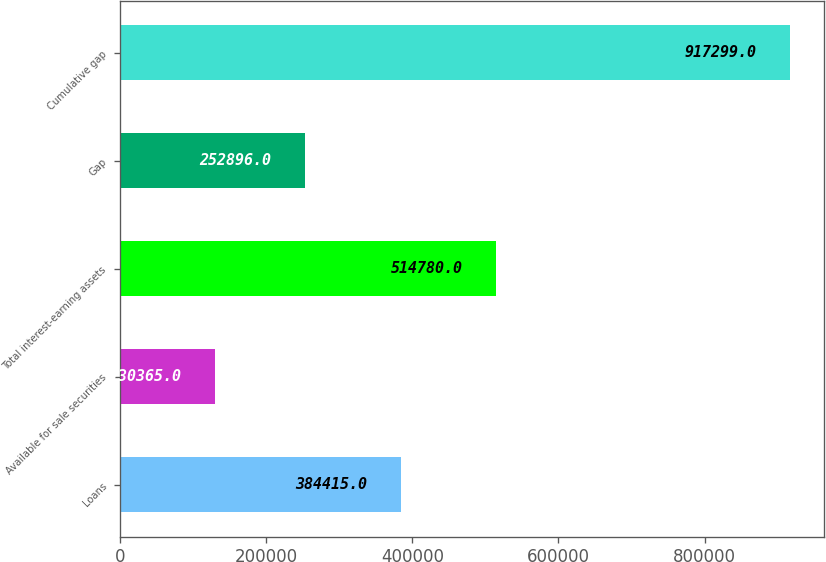Convert chart. <chart><loc_0><loc_0><loc_500><loc_500><bar_chart><fcel>Loans<fcel>Available for sale securities<fcel>Total interest-earning assets<fcel>Gap<fcel>Cumulative gap<nl><fcel>384415<fcel>130365<fcel>514780<fcel>252896<fcel>917299<nl></chart> 